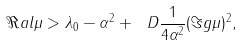<formula> <loc_0><loc_0><loc_500><loc_500>\Re a l \mu > \lambda _ { 0 } - \alpha ^ { 2 } + \ D \frac { 1 } { 4 \alpha ^ { 2 } } ( \Im g \mu ) ^ { 2 } ,</formula> 